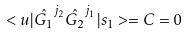Convert formula to latex. <formula><loc_0><loc_0><loc_500><loc_500>< u | \hat { G _ { 1 } } ^ { j _ { 2 } } \hat { G _ { 2 } } ^ { j _ { 1 } } | s _ { 1 } > = C = 0</formula> 